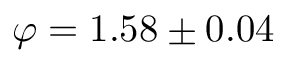<formula> <loc_0><loc_0><loc_500><loc_500>\varphi = 1 . 5 8 \pm 0 . 0 4</formula> 